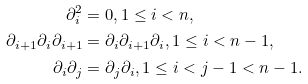Convert formula to latex. <formula><loc_0><loc_0><loc_500><loc_500>\partial _ { i } ^ { 2 } & = 0 , 1 \leq i < n , \\ \partial _ { i + 1 } \partial _ { i } \partial _ { i + 1 } & = \partial _ { i } \partial _ { i + 1 } \partial _ { i } , 1 \leq i < n - 1 , \\ \partial _ { i } \partial _ { j } & = \partial _ { j } \partial _ { i } , 1 \leq i < j - 1 < n - 1 .</formula> 